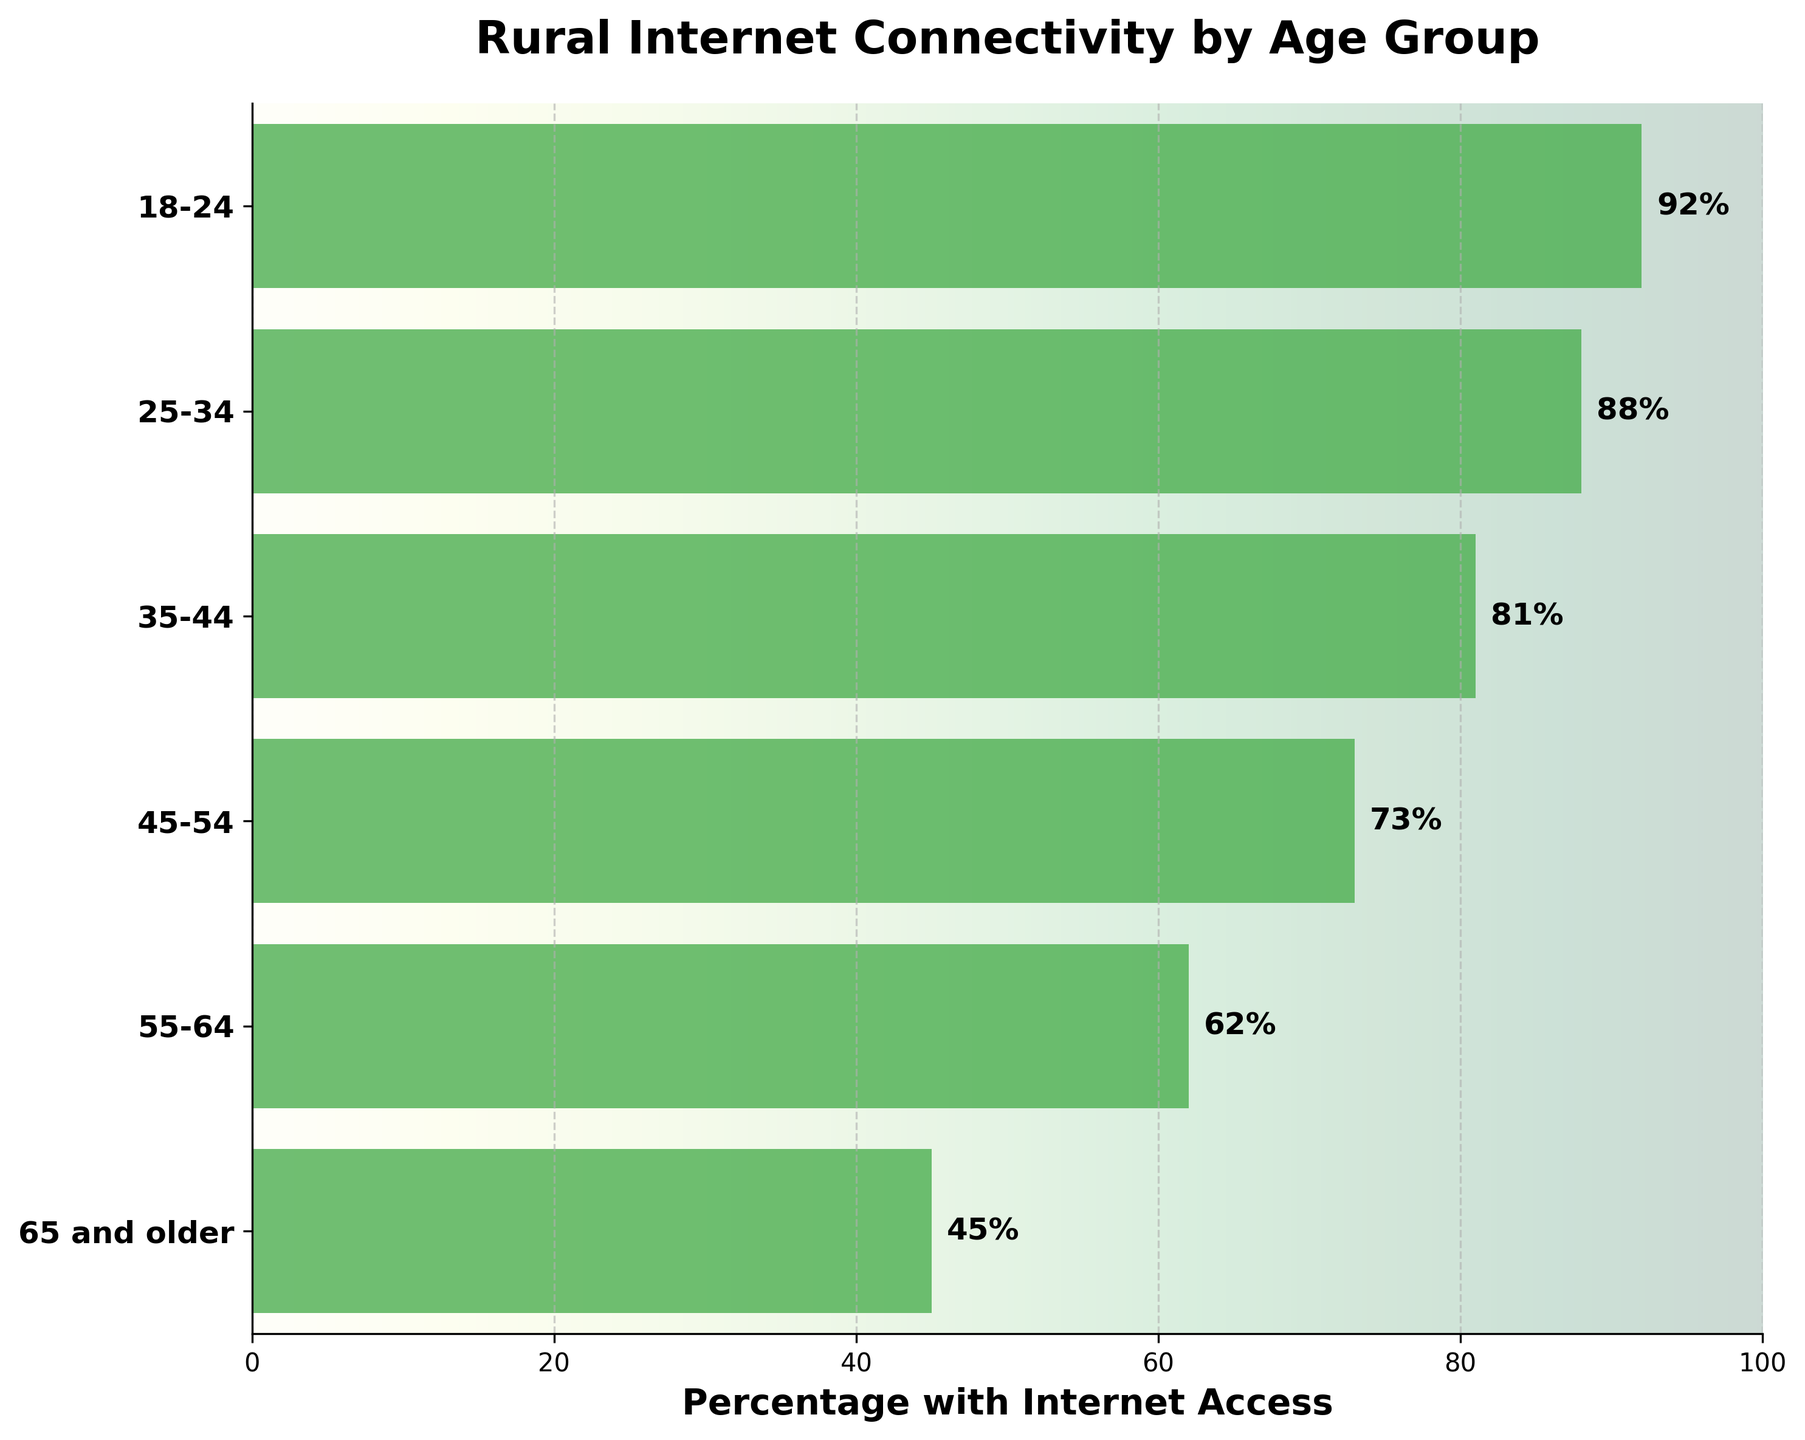What's the title of the chart? The title is usually displayed at the top of the chart. In this case, the title is "Rural Internet Connectivity by Age Group."
Answer: Rural Internet Connectivity by Age Group What does the x-axis represent? The label on the x-axis indicates what it represents. Here, it represents the "Percentage with Internet Access."
Answer: Percentage with Internet Access How many age groups are displayed? To find the number of age groups, count the number of bars (or labels) along the y-axis. The groups listed are: "65 and older," "55-64," "45-54," "35-44," "25-34," and "18-24." This totals to 6 groups.
Answer: 6 Which age group has the highest percentage with internet access? To determine this, look for the longest bar on the chart. The bar corresponding to the "18-24" age group is the longest, indicating the highest percentage.
Answer: 18-24 What's the percentage with internet access for the age group "35-44"? Locate the bar corresponding to the "35-44" age group and read its length. The label shows "81%."
Answer: 81% How much is the percentage difference in internet access between the age groups "55-64" and "65 and older"? Find the values for "55-64" (62%) and "65 and older" (45%). Subtract the smaller percentage from the larger percentage to find the difference: 62% - 45% = 17%.
Answer: 17% What's the average percentage of internet access for the age groups "35-44" and "45-54"? Find the values for "35-44" (81%) and "45-54" (73%). Add them together and divide by 2 to get the average: (81 + 73) / 2 = 77%.
Answer: 77% How does the percentage of internet access for the "65 and older" group compare to the "25-34" group? Find the values for both groups: "65 and older" (45%) and "25-34" (88%). Compare to see that 45% is significantly less than 88%.
Answer: Less than If you were to make a horizontal cut across the chart at 80%, how many age groups would fall below this line? Look at the bar lengths and identify those below 80%. The groups "65 and older" (45%), "55-64" (62%), and "45-54" (73%) fall below 80%. This totals to 3 age groups.
Answer: 3 